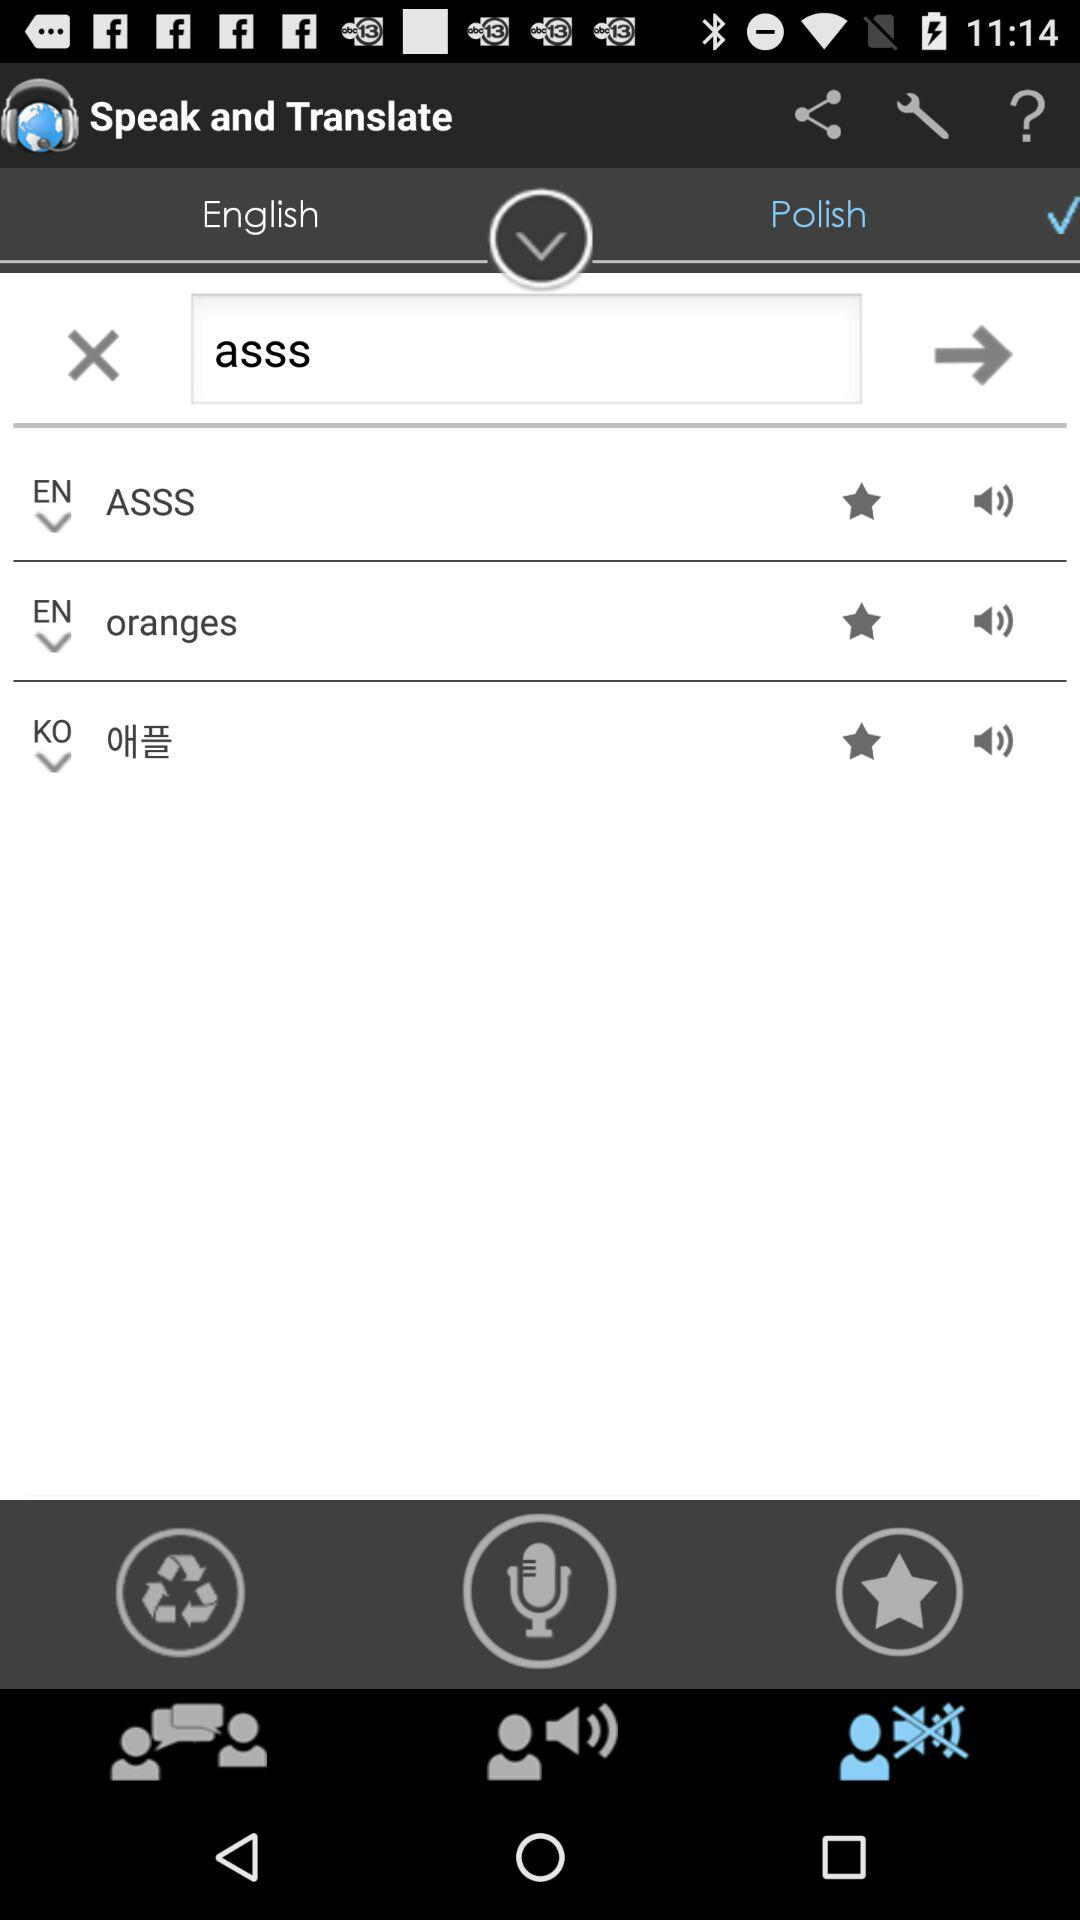How many recordings are there?
When the provided information is insufficient, respond with <no answer>. <no answer> 